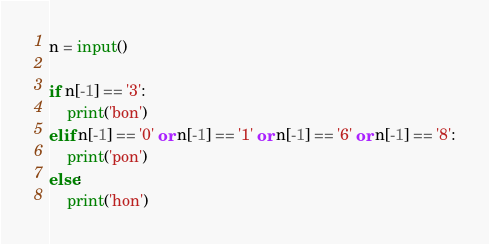Convert code to text. <code><loc_0><loc_0><loc_500><loc_500><_Python_>n = input()

if n[-1] == '3':
    print('bon')
elif n[-1] == '0' or n[-1] == '1' or n[-1] == '6' or n[-1] == '8':
    print('pon')
else:
    print('hon')</code> 